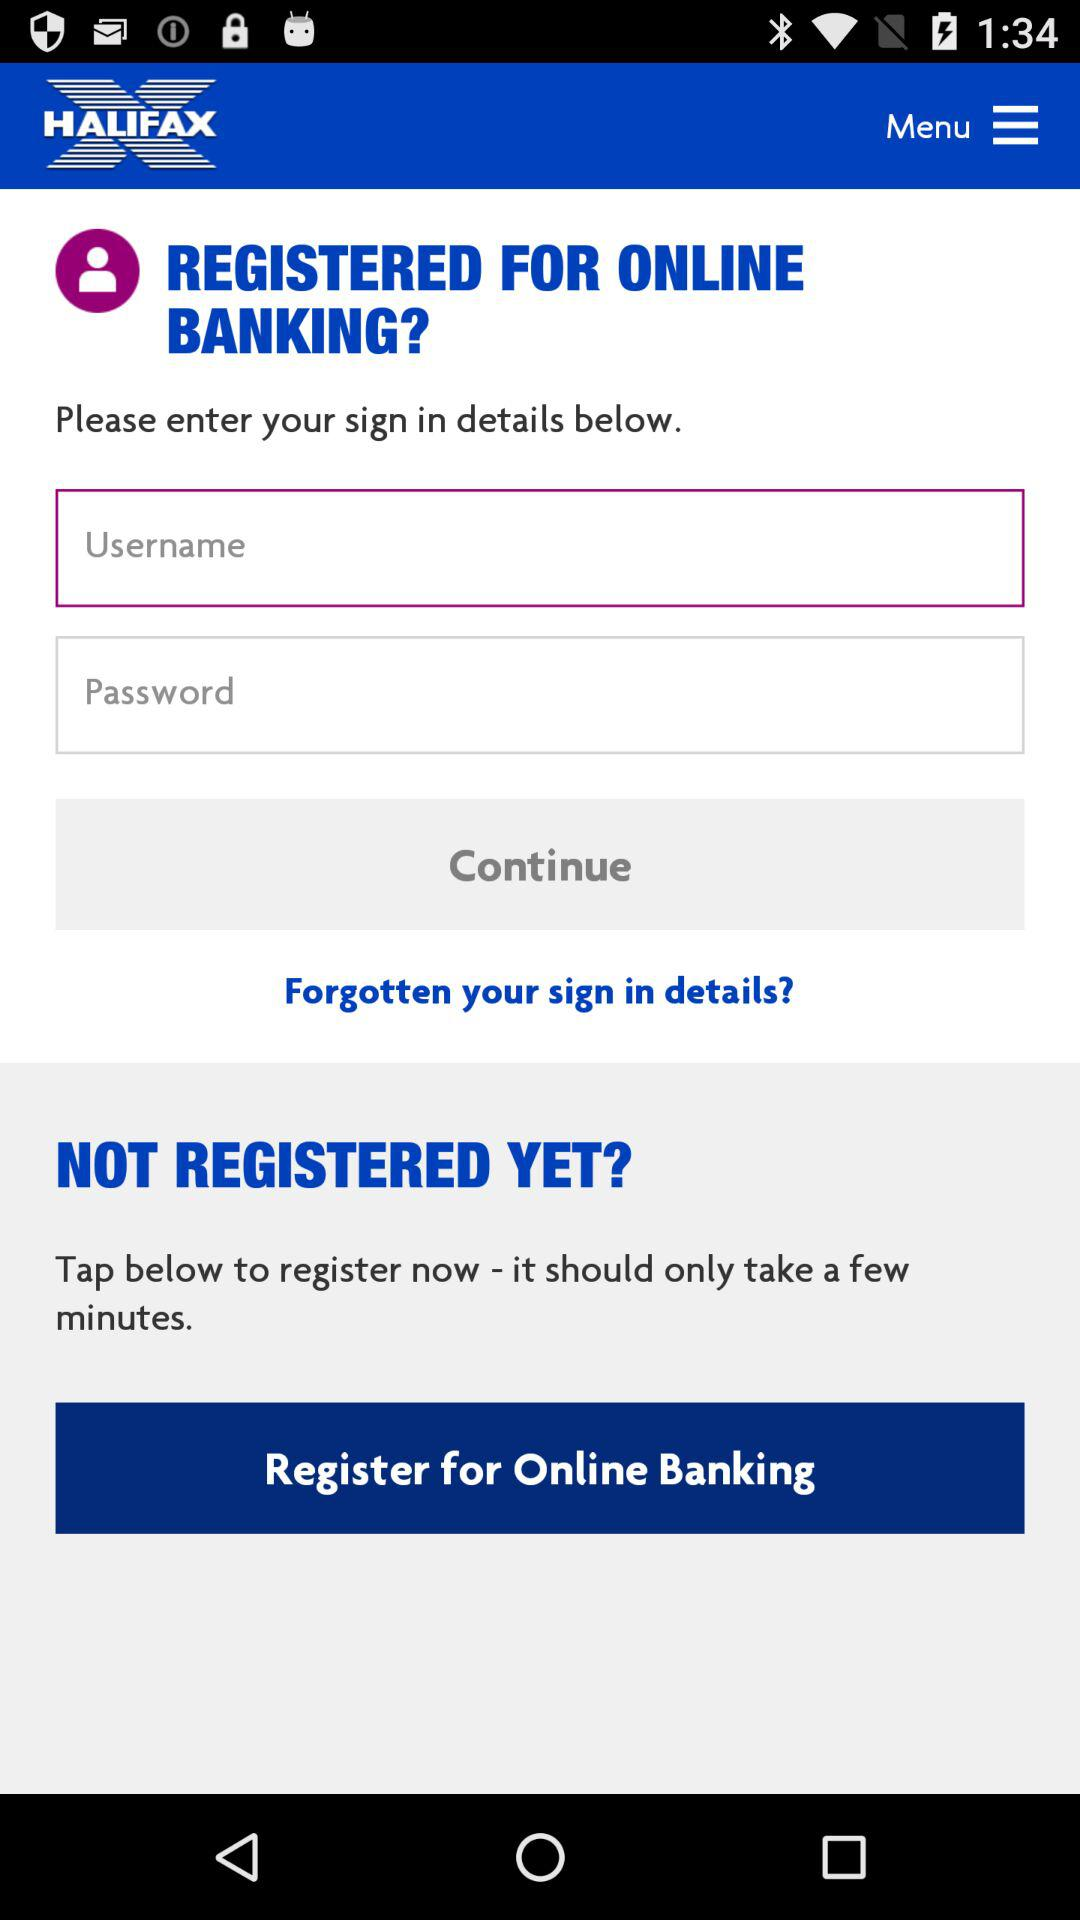What is the application name? The application name is "Halifax". 